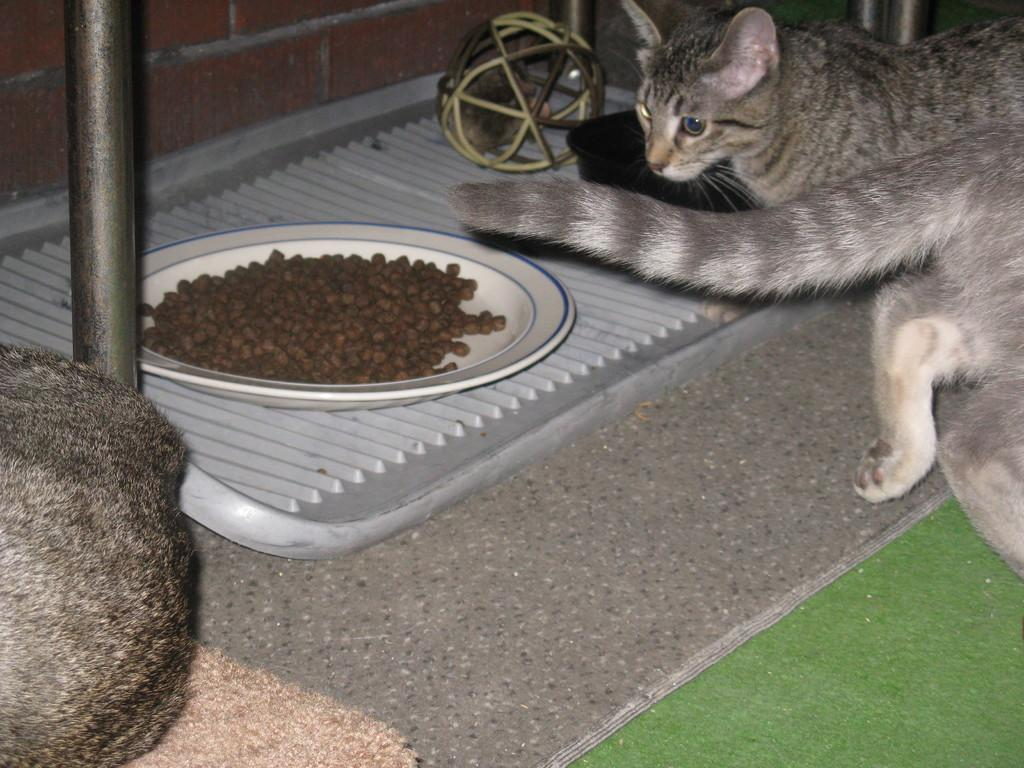What type of animal is in the image? There is a cat in the image. What is the cat doing in the image? The cat is sitting. What object is present in the image besides the cat? There is a plate in the image. What is on the plate in the image? There is something in the plate. Can you tell me the name of the lawyer who is an expert on cat behavior in the image? There is no lawyer or expert on cat behavior present in the image; it only features a cat sitting and a plate. 